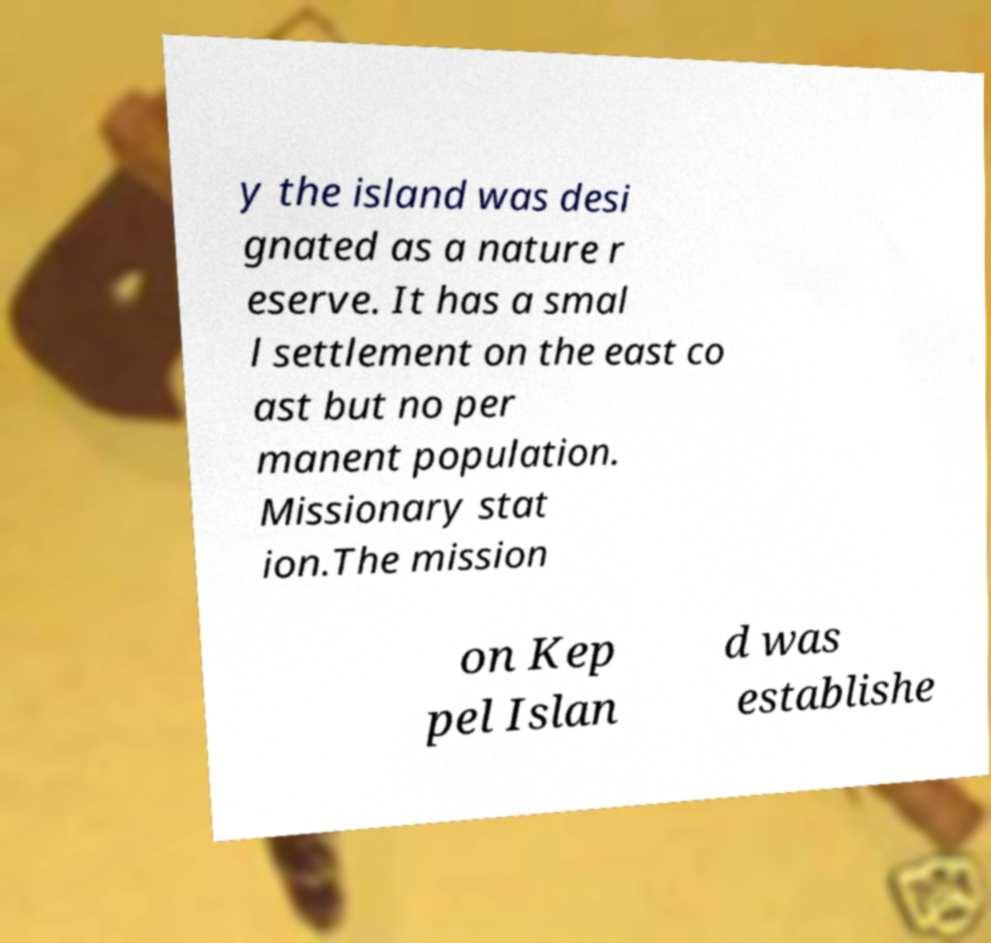Please identify and transcribe the text found in this image. y the island was desi gnated as a nature r eserve. It has a smal l settlement on the east co ast but no per manent population. Missionary stat ion.The mission on Kep pel Islan d was establishe 